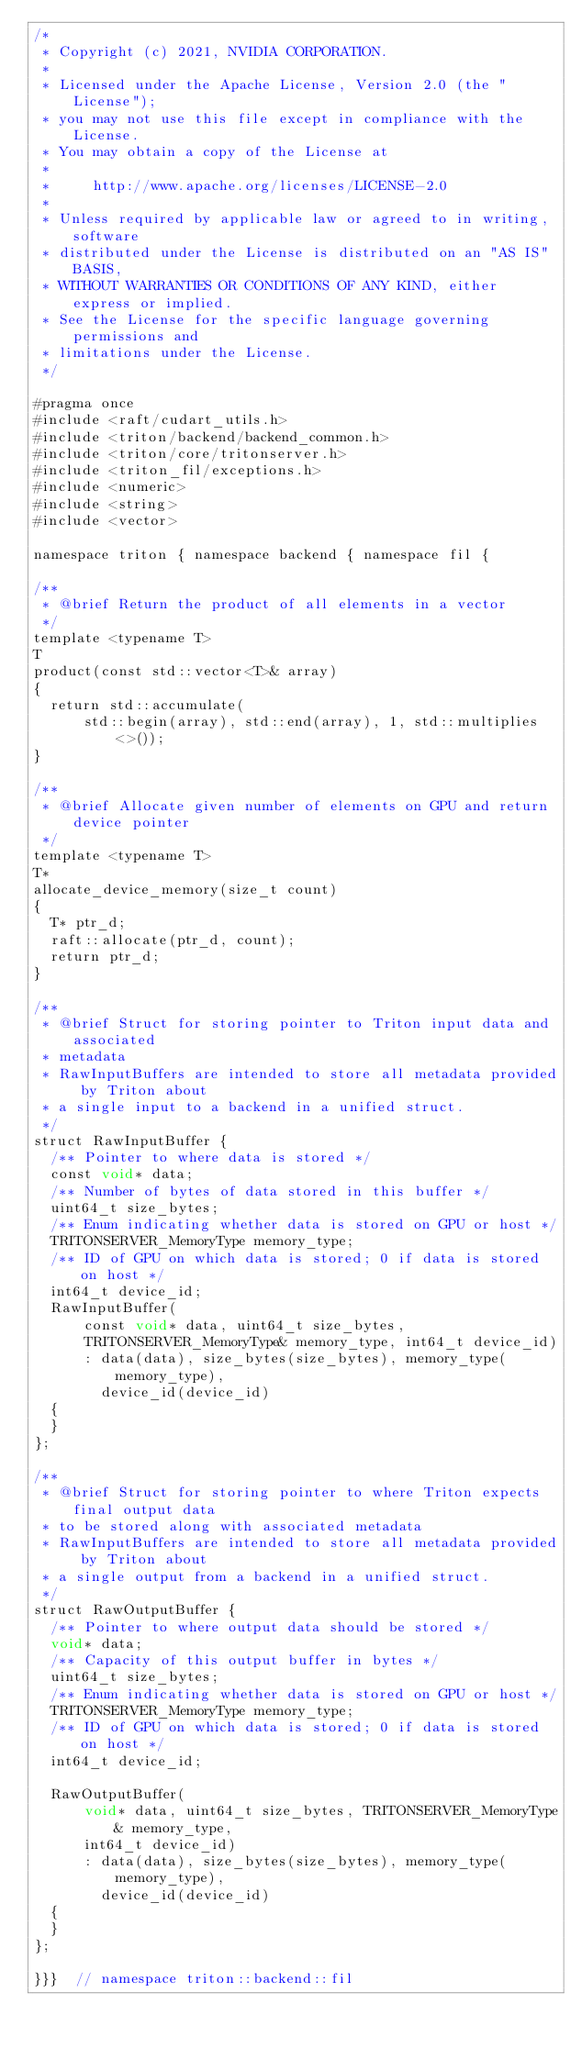<code> <loc_0><loc_0><loc_500><loc_500><_Cuda_>/*
 * Copyright (c) 2021, NVIDIA CORPORATION.
 *
 * Licensed under the Apache License, Version 2.0 (the "License");
 * you may not use this file except in compliance with the License.
 * You may obtain a copy of the License at
 *
 *     http://www.apache.org/licenses/LICENSE-2.0
 *
 * Unless required by applicable law or agreed to in writing, software
 * distributed under the License is distributed on an "AS IS" BASIS,
 * WITHOUT WARRANTIES OR CONDITIONS OF ANY KIND, either express or implied.
 * See the License for the specific language governing permissions and
 * limitations under the License.
 */

#pragma once
#include <raft/cudart_utils.h>
#include <triton/backend/backend_common.h>
#include <triton/core/tritonserver.h>
#include <triton_fil/exceptions.h>
#include <numeric>
#include <string>
#include <vector>

namespace triton { namespace backend { namespace fil {

/**
 * @brief Return the product of all elements in a vector
 */
template <typename T>
T
product(const std::vector<T>& array)
{
  return std::accumulate(
      std::begin(array), std::end(array), 1, std::multiplies<>());
}

/**
 * @brief Allocate given number of elements on GPU and return device pointer
 */
template <typename T>
T*
allocate_device_memory(size_t count)
{
  T* ptr_d;
  raft::allocate(ptr_d, count);
  return ptr_d;
}

/**
 * @brief Struct for storing pointer to Triton input data and associated
 * metadata
 * RawInputBuffers are intended to store all metadata provided by Triton about
 * a single input to a backend in a unified struct.
 */
struct RawInputBuffer {
  /** Pointer to where data is stored */
  const void* data;
  /** Number of bytes of data stored in this buffer */
  uint64_t size_bytes;
  /** Enum indicating whether data is stored on GPU or host */
  TRITONSERVER_MemoryType memory_type;
  /** ID of GPU on which data is stored; 0 if data is stored on host */
  int64_t device_id;
  RawInputBuffer(
      const void* data, uint64_t size_bytes,
      TRITONSERVER_MemoryType& memory_type, int64_t device_id)
      : data(data), size_bytes(size_bytes), memory_type(memory_type),
        device_id(device_id)
  {
  }
};

/**
 * @brief Struct for storing pointer to where Triton expects final output data
 * to be stored along with associated metadata
 * RawInputBuffers are intended to store all metadata provided by Triton about
 * a single output from a backend in a unified struct.
 */
struct RawOutputBuffer {
  /** Pointer to where output data should be stored */
  void* data;
  /** Capacity of this output buffer in bytes */
  uint64_t size_bytes;
  /** Enum indicating whether data is stored on GPU or host */
  TRITONSERVER_MemoryType memory_type;
  /** ID of GPU on which data is stored; 0 if data is stored on host */
  int64_t device_id;

  RawOutputBuffer(
      void* data, uint64_t size_bytes, TRITONSERVER_MemoryType& memory_type,
      int64_t device_id)
      : data(data), size_bytes(size_bytes), memory_type(memory_type),
        device_id(device_id)
  {
  }
};

}}}  // namespace triton::backend::fil
</code> 